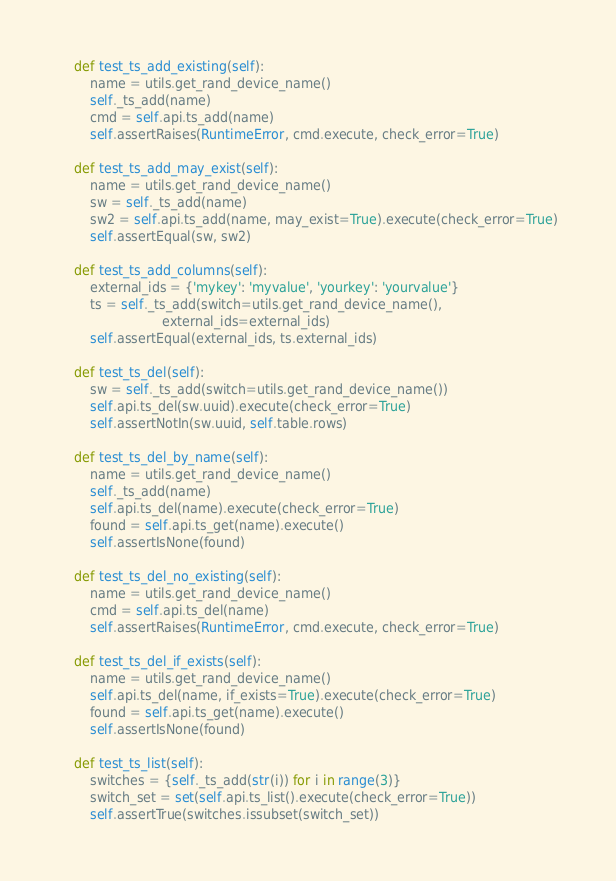Convert code to text. <code><loc_0><loc_0><loc_500><loc_500><_Python_>
    def test_ts_add_existing(self):
        name = utils.get_rand_device_name()
        self._ts_add(name)
        cmd = self.api.ts_add(name)
        self.assertRaises(RuntimeError, cmd.execute, check_error=True)

    def test_ts_add_may_exist(self):
        name = utils.get_rand_device_name()
        sw = self._ts_add(name)
        sw2 = self.api.ts_add(name, may_exist=True).execute(check_error=True)
        self.assertEqual(sw, sw2)

    def test_ts_add_columns(self):
        external_ids = {'mykey': 'myvalue', 'yourkey': 'yourvalue'}
        ts = self._ts_add(switch=utils.get_rand_device_name(),
                          external_ids=external_ids)
        self.assertEqual(external_ids, ts.external_ids)

    def test_ts_del(self):
        sw = self._ts_add(switch=utils.get_rand_device_name())
        self.api.ts_del(sw.uuid).execute(check_error=True)
        self.assertNotIn(sw.uuid, self.table.rows)

    def test_ts_del_by_name(self):
        name = utils.get_rand_device_name()
        self._ts_add(name)
        self.api.ts_del(name).execute(check_error=True)
        found = self.api.ts_get(name).execute()
        self.assertIsNone(found)

    def test_ts_del_no_existing(self):
        name = utils.get_rand_device_name()
        cmd = self.api.ts_del(name)
        self.assertRaises(RuntimeError, cmd.execute, check_error=True)

    def test_ts_del_if_exists(self):
        name = utils.get_rand_device_name()
        self.api.ts_del(name, if_exists=True).execute(check_error=True)
        found = self.api.ts_get(name).execute()
        self.assertIsNone(found)

    def test_ts_list(self):
        switches = {self._ts_add(str(i)) for i in range(3)}
        switch_set = set(self.api.ts_list().execute(check_error=True))
        self.assertTrue(switches.issubset(switch_set))
</code> 